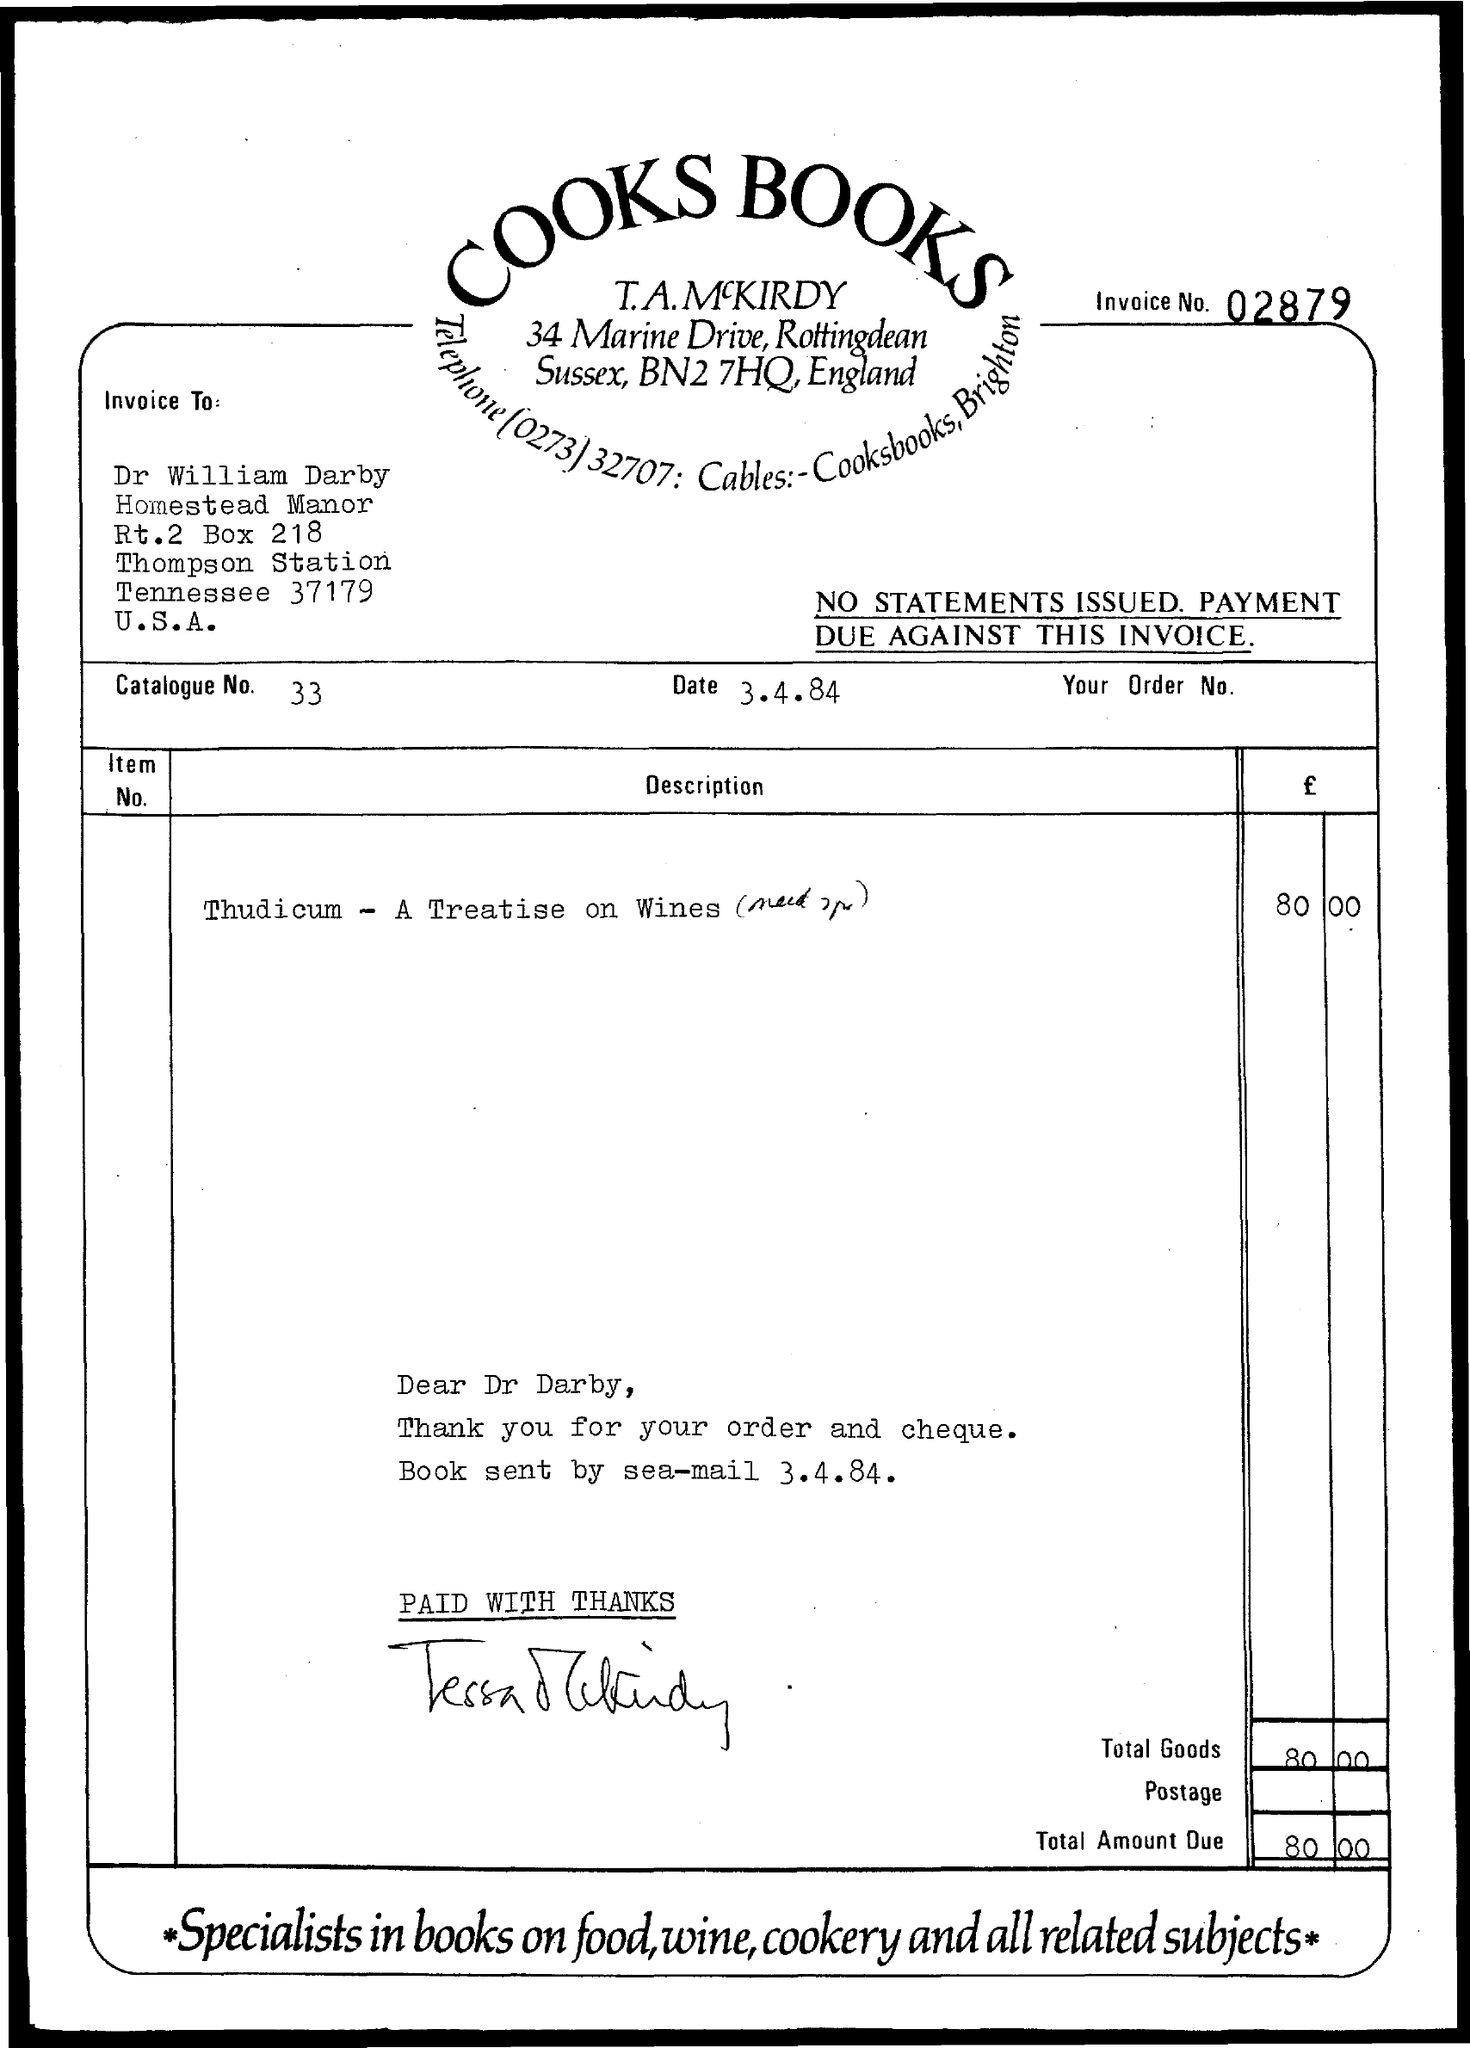List a handful of essential elements in this visual. What is the date mentioned in this document that is represented by "3.4.84.."? What is the invoice number given? 02879... The payee's name on the invoice is Dr. William Darby. Which company issued the invoice, specifically COOKS BOOKS.. The total amount due in the invoice is 80.00. 